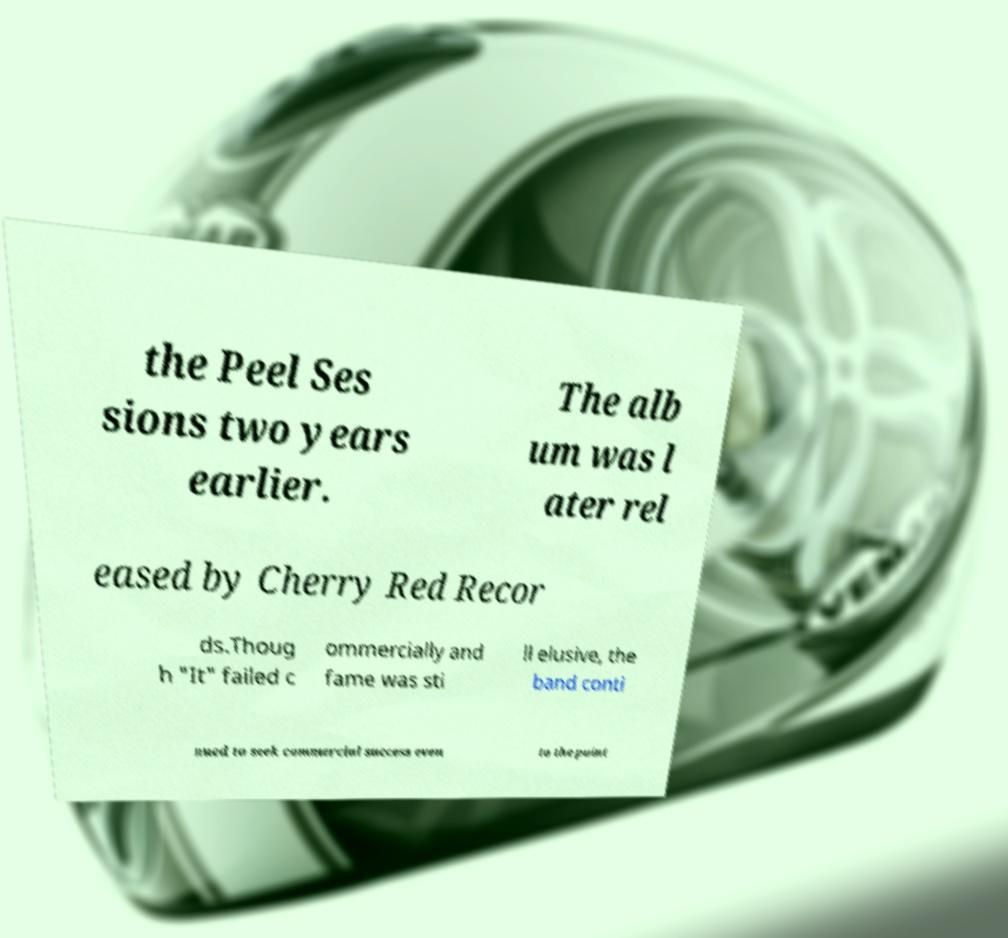I need the written content from this picture converted into text. Can you do that? the Peel Ses sions two years earlier. The alb um was l ater rel eased by Cherry Red Recor ds.Thoug h "It" failed c ommercially and fame was sti ll elusive, the band conti nued to seek commercial success even to the point 